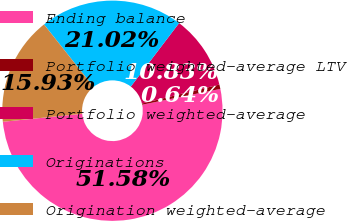Convert chart to OTSL. <chart><loc_0><loc_0><loc_500><loc_500><pie_chart><fcel>Ending balance<fcel>Portfolio weighted-average LTV<fcel>Portfolio weighted-average<fcel>Originations<fcel>Origination weighted-average<nl><fcel>51.58%<fcel>0.64%<fcel>10.83%<fcel>21.02%<fcel>15.93%<nl></chart> 